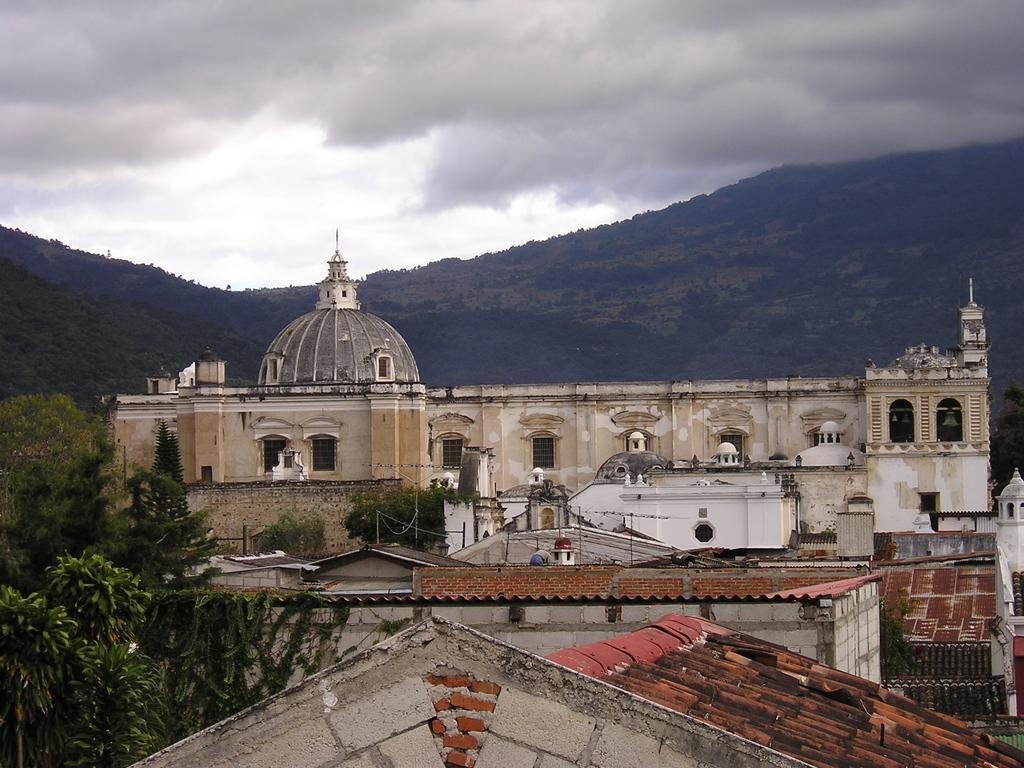Please provide a concise description of this image. In the center of the image we can see building. At the bottom of the image we can see house. On the left side of the image we can see trees. In the background we can see hills, trees, sky and clouds. 